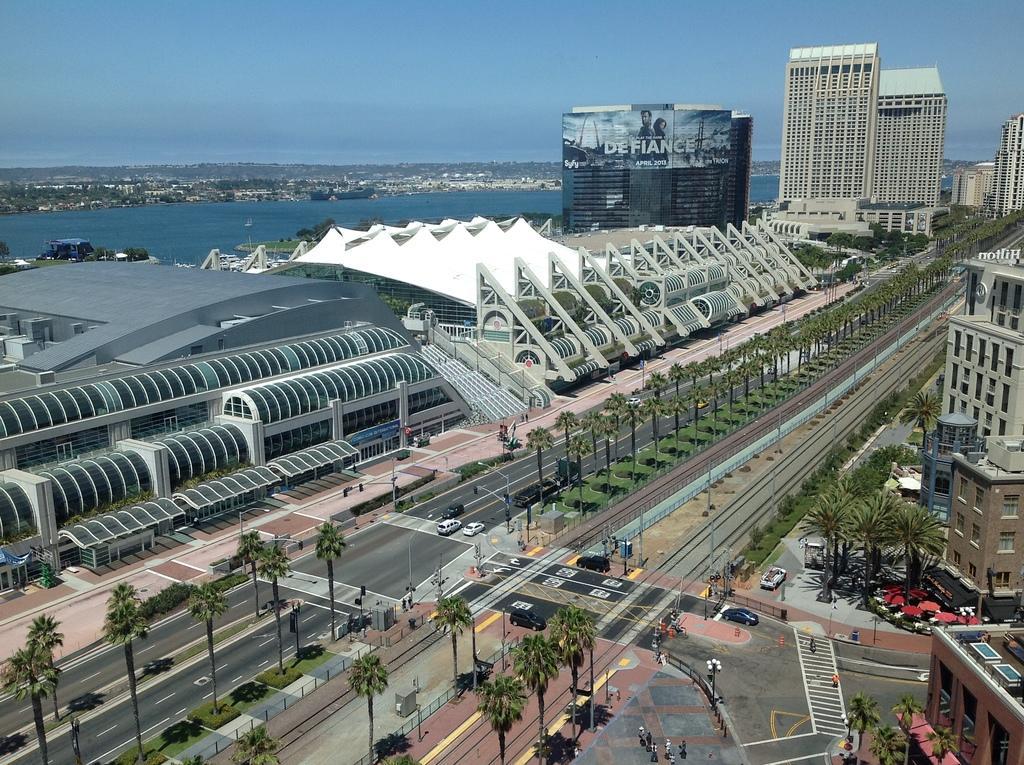Could you give a brief overview of what you see in this image? In this image we can see a few buildings, few trees, grass, few vehicles on the road, few people on the pavements, water and the sky. 